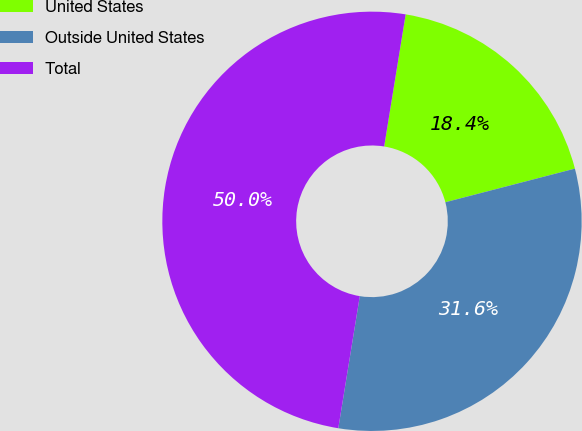<chart> <loc_0><loc_0><loc_500><loc_500><pie_chart><fcel>United States<fcel>Outside United States<fcel>Total<nl><fcel>18.39%<fcel>31.61%<fcel>50.0%<nl></chart> 